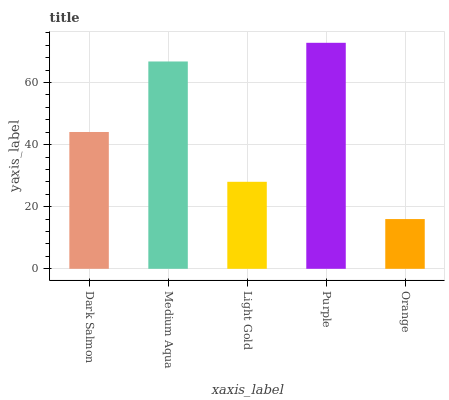Is Medium Aqua the minimum?
Answer yes or no. No. Is Medium Aqua the maximum?
Answer yes or no. No. Is Medium Aqua greater than Dark Salmon?
Answer yes or no. Yes. Is Dark Salmon less than Medium Aqua?
Answer yes or no. Yes. Is Dark Salmon greater than Medium Aqua?
Answer yes or no. No. Is Medium Aqua less than Dark Salmon?
Answer yes or no. No. Is Dark Salmon the high median?
Answer yes or no. Yes. Is Dark Salmon the low median?
Answer yes or no. Yes. Is Purple the high median?
Answer yes or no. No. Is Medium Aqua the low median?
Answer yes or no. No. 